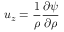Convert formula to latex. <formula><loc_0><loc_0><loc_500><loc_500>u _ { z } = \frac { 1 } { \rho } \frac { \partial \psi } { \partial \rho }</formula> 